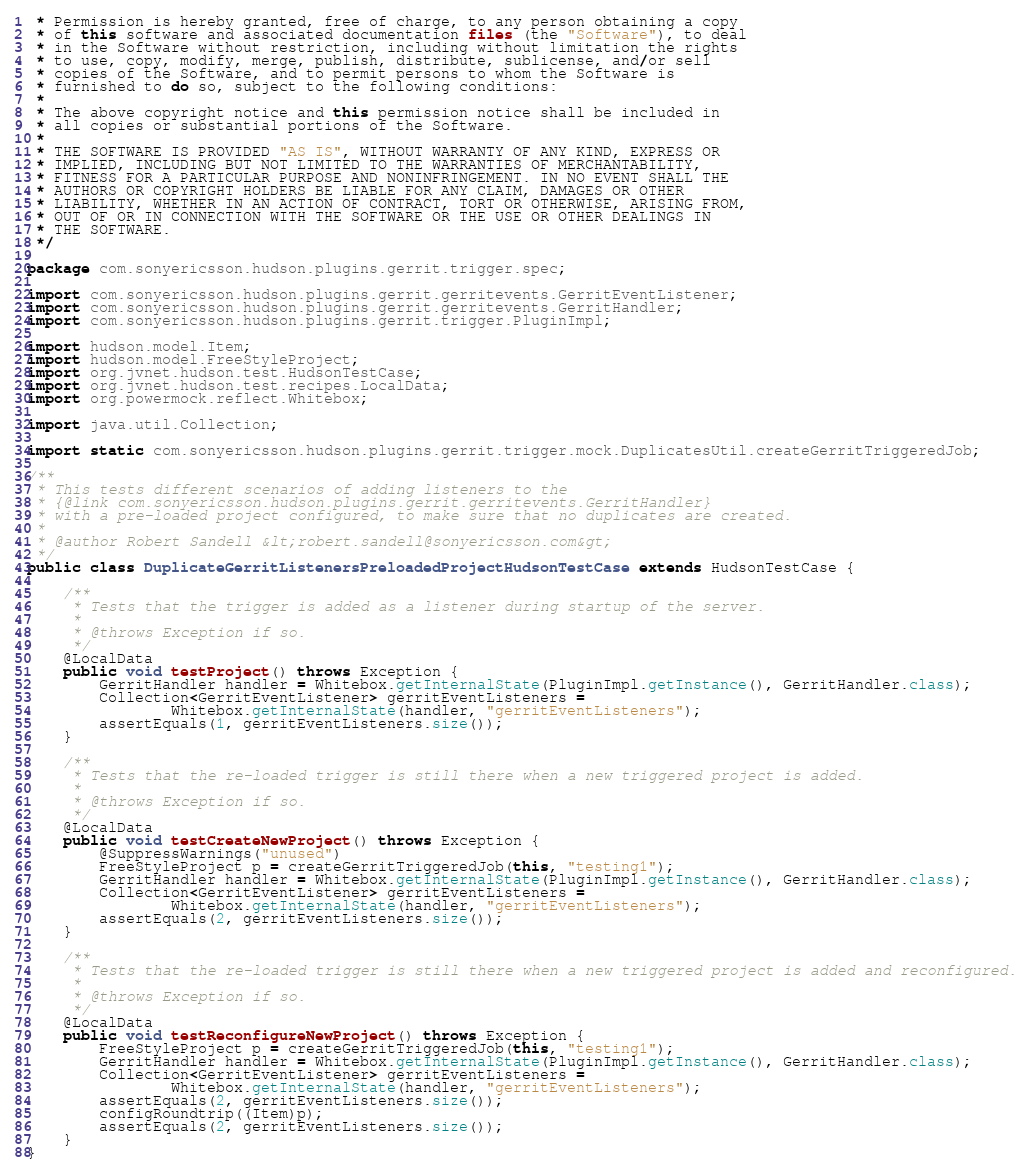<code> <loc_0><loc_0><loc_500><loc_500><_Java_> * Permission is hereby granted, free of charge, to any person obtaining a copy
 * of this software and associated documentation files (the "Software"), to deal
 * in the Software without restriction, including without limitation the rights
 * to use, copy, modify, merge, publish, distribute, sublicense, and/or sell
 * copies of the Software, and to permit persons to whom the Software is
 * furnished to do so, subject to the following conditions:
 *
 * The above copyright notice and this permission notice shall be included in
 * all copies or substantial portions of the Software.
 *
 * THE SOFTWARE IS PROVIDED "AS IS", WITHOUT WARRANTY OF ANY KIND, EXPRESS OR
 * IMPLIED, INCLUDING BUT NOT LIMITED TO THE WARRANTIES OF MERCHANTABILITY,
 * FITNESS FOR A PARTICULAR PURPOSE AND NONINFRINGEMENT. IN NO EVENT SHALL THE
 * AUTHORS OR COPYRIGHT HOLDERS BE LIABLE FOR ANY CLAIM, DAMAGES OR OTHER
 * LIABILITY, WHETHER IN AN ACTION OF CONTRACT, TORT OR OTHERWISE, ARISING FROM,
 * OUT OF OR IN CONNECTION WITH THE SOFTWARE OR THE USE OR OTHER DEALINGS IN
 * THE SOFTWARE.
 */

package com.sonyericsson.hudson.plugins.gerrit.trigger.spec;

import com.sonyericsson.hudson.plugins.gerrit.gerritevents.GerritEventListener;
import com.sonyericsson.hudson.plugins.gerrit.gerritevents.GerritHandler;
import com.sonyericsson.hudson.plugins.gerrit.trigger.PluginImpl;

import hudson.model.Item;
import hudson.model.FreeStyleProject;
import org.jvnet.hudson.test.HudsonTestCase;
import org.jvnet.hudson.test.recipes.LocalData;
import org.powermock.reflect.Whitebox;

import java.util.Collection;

import static com.sonyericsson.hudson.plugins.gerrit.trigger.mock.DuplicatesUtil.createGerritTriggeredJob;

/**
 * This tests different scenarios of adding listeners to the
 * {@link com.sonyericsson.hudson.plugins.gerrit.gerritevents.GerritHandler}
 * with a pre-loaded project configured, to make sure that no duplicates are created.
 *
 * @author Robert Sandell &lt;robert.sandell@sonyericsson.com&gt;
 */
public class DuplicateGerritListenersPreloadedProjectHudsonTestCase extends HudsonTestCase {

    /**
     * Tests that the trigger is added as a listener during startup of the server.
     *
     * @throws Exception if so.
     */
    @LocalData
    public void testProject() throws Exception {
        GerritHandler handler = Whitebox.getInternalState(PluginImpl.getInstance(), GerritHandler.class);
        Collection<GerritEventListener> gerritEventListeners =
                Whitebox.getInternalState(handler, "gerritEventListeners");
        assertEquals(1, gerritEventListeners.size());
    }

    /**
     * Tests that the re-loaded trigger is still there when a new triggered project is added.
     *
     * @throws Exception if so.
     */
    @LocalData
    public void testCreateNewProject() throws Exception {
        @SuppressWarnings("unused")
        FreeStyleProject p = createGerritTriggeredJob(this, "testing1");
        GerritHandler handler = Whitebox.getInternalState(PluginImpl.getInstance(), GerritHandler.class);
        Collection<GerritEventListener> gerritEventListeners =
                Whitebox.getInternalState(handler, "gerritEventListeners");
        assertEquals(2, gerritEventListeners.size());
    }

    /**
     * Tests that the re-loaded trigger is still there when a new triggered project is added and reconfigured.
     *
     * @throws Exception if so.
     */
    @LocalData
    public void testReconfigureNewProject() throws Exception {
        FreeStyleProject p = createGerritTriggeredJob(this, "testing1");
        GerritHandler handler = Whitebox.getInternalState(PluginImpl.getInstance(), GerritHandler.class);
        Collection<GerritEventListener> gerritEventListeners =
                Whitebox.getInternalState(handler, "gerritEventListeners");
        assertEquals(2, gerritEventListeners.size());
        configRoundtrip((Item)p);
        assertEquals(2, gerritEventListeners.size());
    }
}
</code> 